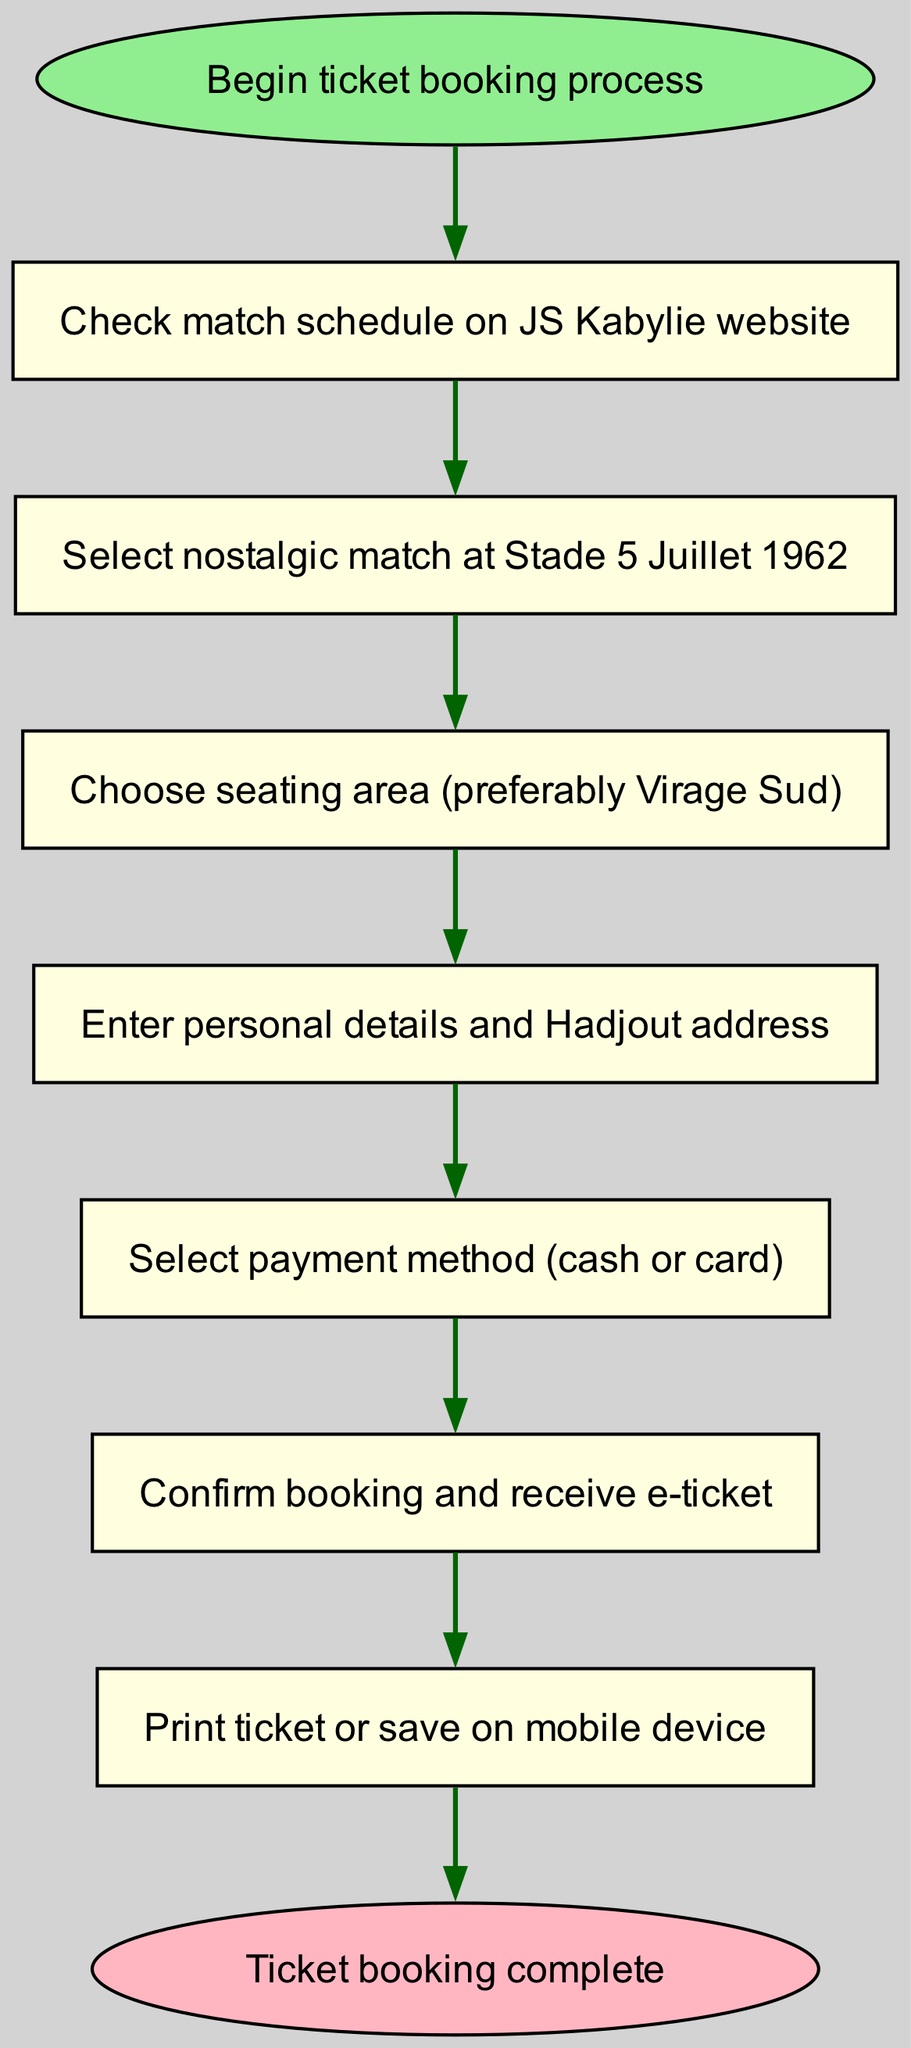What is the first step in the ticket booking process? The first step is specified in the "start" node, which indicates the beginning of the ticket booking process. The diagram shows that the first action is to check the match schedule.
Answer: Check match schedule on JS Kabylie website How many total steps are there in the booking process? By counting the nodes listed in the diagram from the start to the end, we identify there are 7 steps between the starting point and completion.
Answer: 7 Which seating area is suggested for booking tickets? The step that specifies the seating area is found in step 3, which indicates a preference for a specific seating area. The diagram states it is advisable to choose the "Virage Sud."
Answer: Virage Sud What is the last action in the booking process? The diagram's last step leads into the end node, and the action taken just before reaching the end is printing the ticket or saving it on a mobile device. Thus, this is the final action in the flow.
Answer: Print ticket or save on mobile device What is the connection between steps 4 and 5? The connection is indicated through the edge directly linking step 4, which involves entering personal details, to step 5, where the payment method is selected. This shows the flow from providing details to payment selection.
Answer: Select payment method (cash or card) 